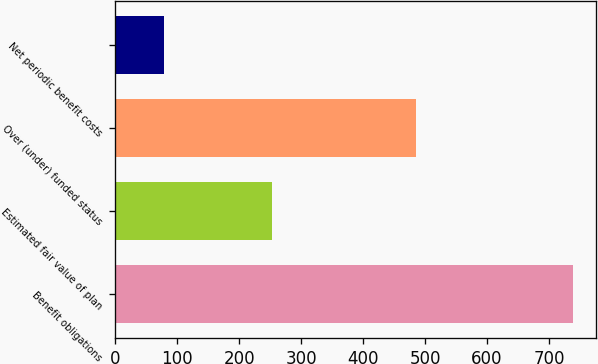Convert chart to OTSL. <chart><loc_0><loc_0><loc_500><loc_500><bar_chart><fcel>Benefit obligations<fcel>Estimated fair value of plan<fcel>Over (under) funded status<fcel>Net periodic benefit costs<nl><fcel>739<fcel>253<fcel>486<fcel>79<nl></chart> 